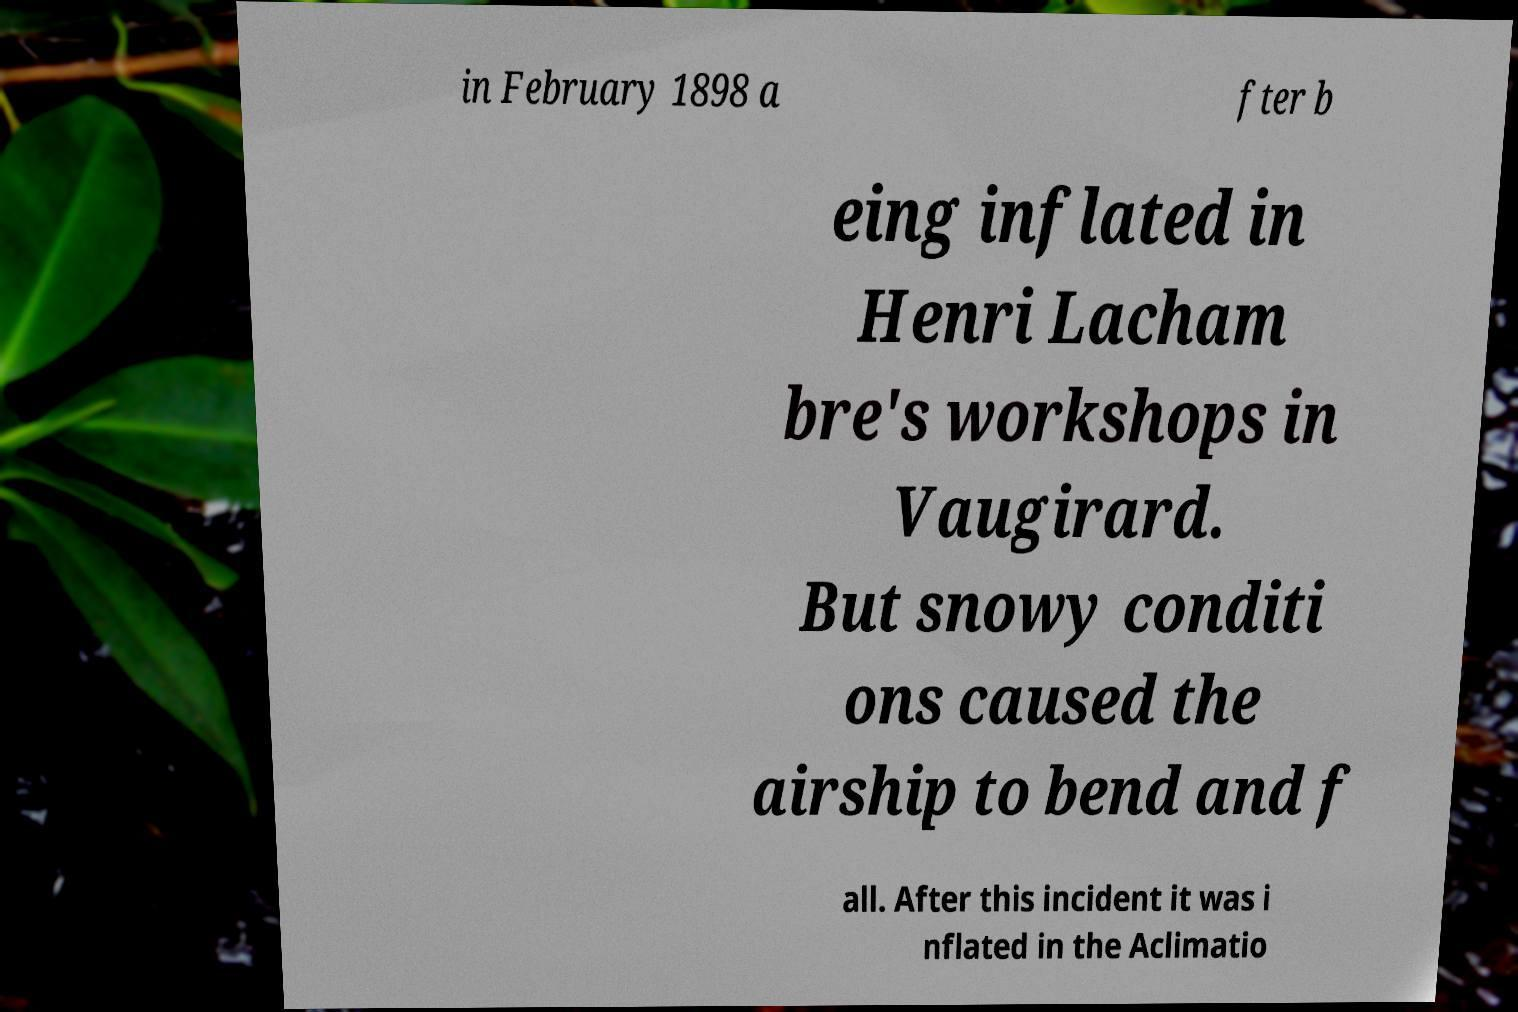Please identify and transcribe the text found in this image. in February 1898 a fter b eing inflated in Henri Lacham bre's workshops in Vaugirard. But snowy conditi ons caused the airship to bend and f all. After this incident it was i nflated in the Aclimatio 